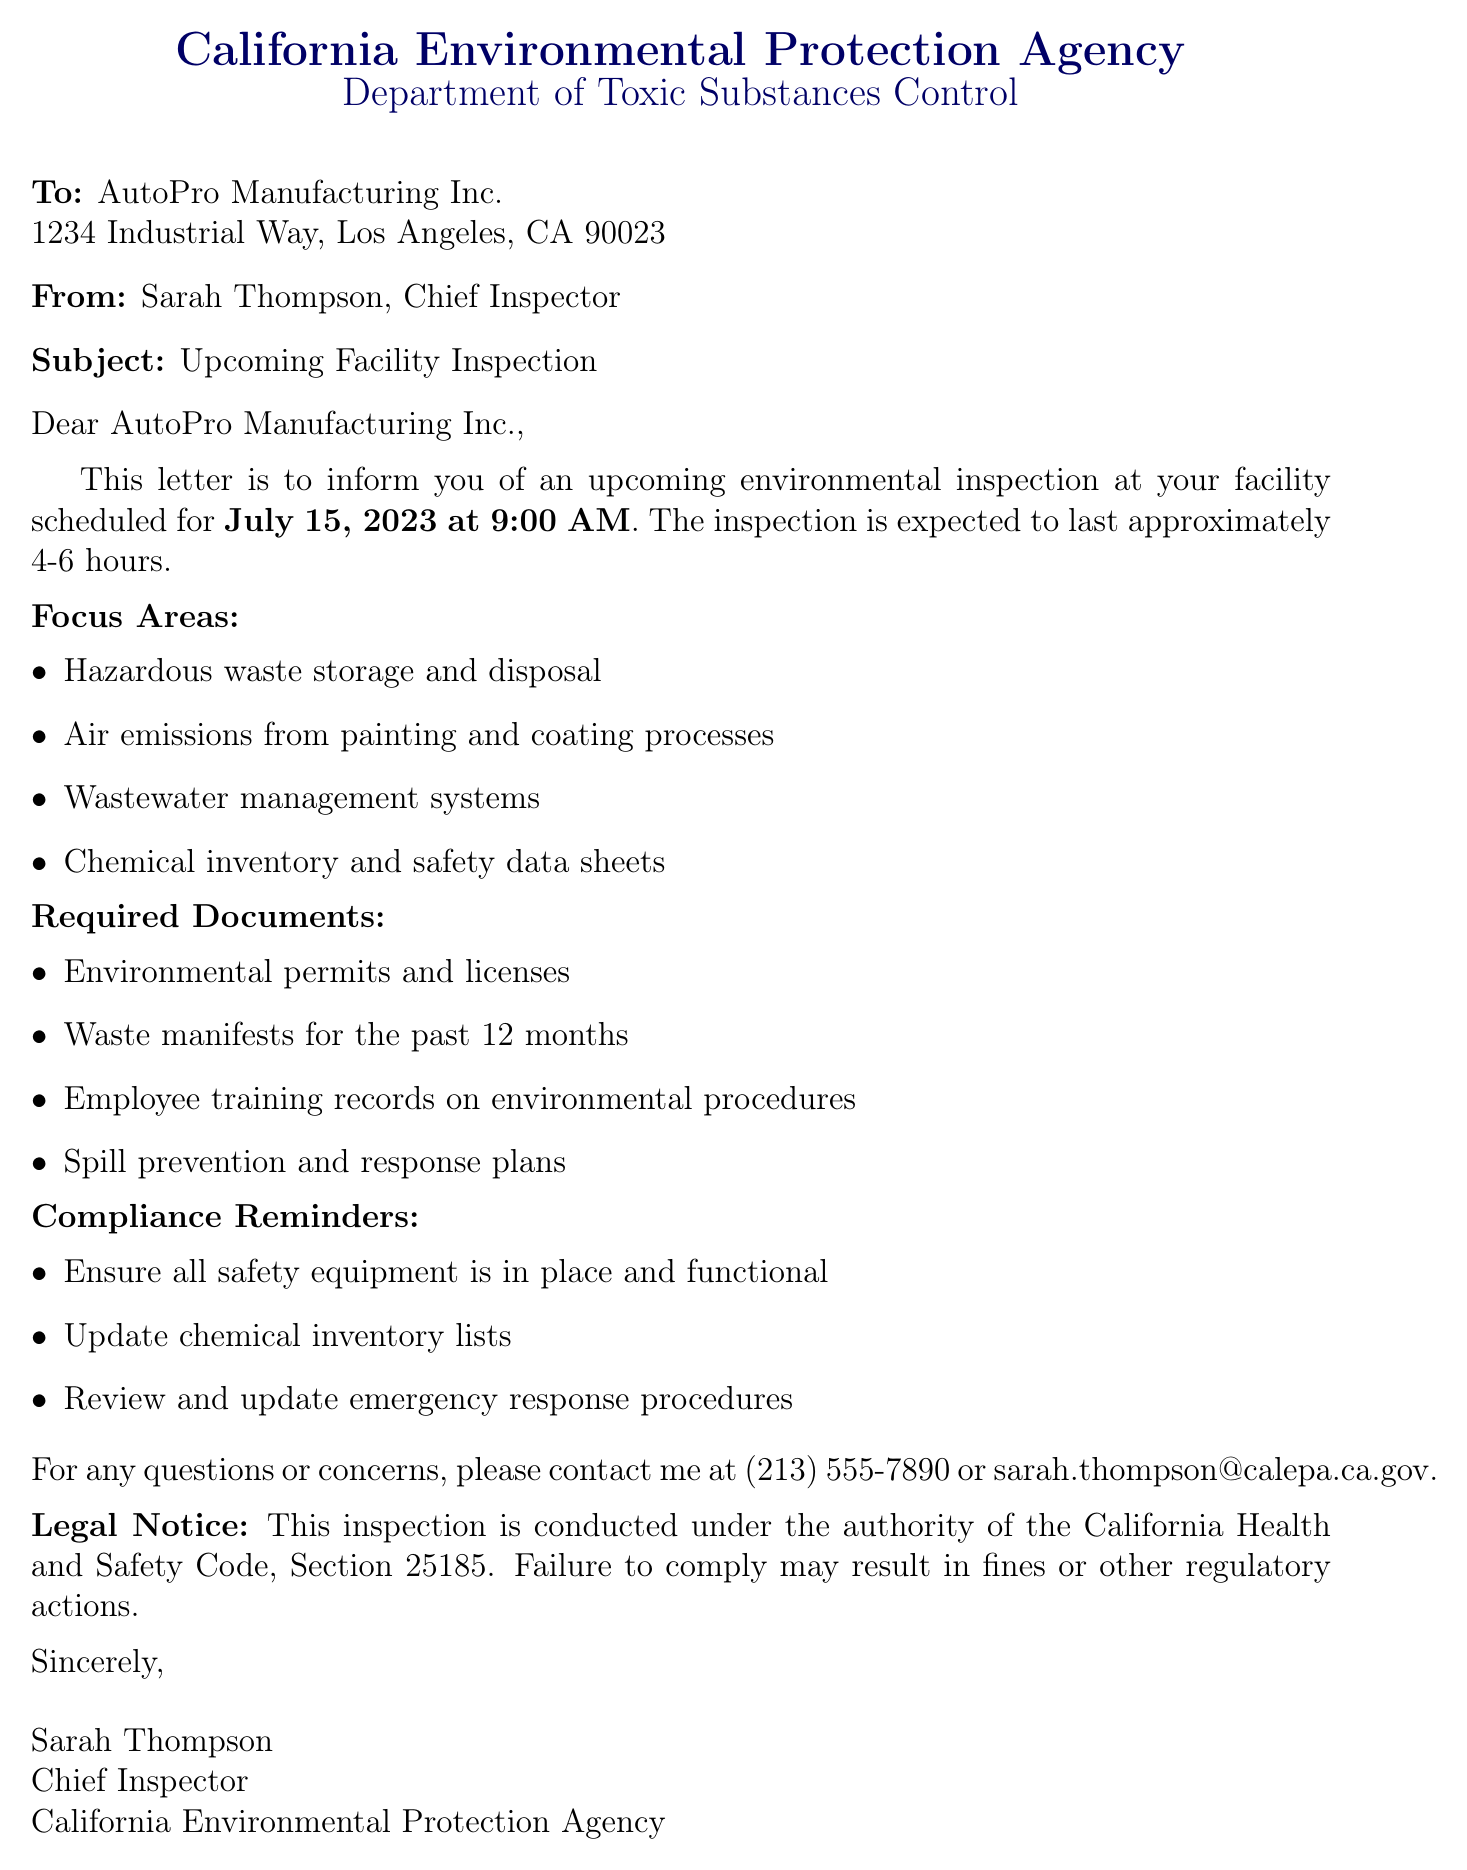What is the inspection date? The inspection date is specifically mentioned in the document as July 15, 2023.
Answer: July 15, 2023 Who is the Chief Inspector? The document states that Sarah Thompson holds the position of Chief Inspector.
Answer: Sarah Thompson How long is the inspection expected to last? The document indicates that the inspection will last approximately 4-6 hours.
Answer: Approximately 4-6 hours What are the focus areas of the inspection? The document lists several focus areas including hazardous waste storage and disposal, air emissions, and others.
Answer: Hazardous waste storage and disposal, air emissions from painting and coating processes, wastewater management systems, chemical inventory and safety data sheets What documents are required for the inspection? The document specifies that environmental permits, waste manifests, employee training records, and spill prevention plans are required.
Answer: Environmental permits and licenses, waste manifests for the past 12 months, employee training records on environmental procedures, spill prevention and response plans What is the contact phone number provided? The document includes a contact phone number for inquiries, which is (213) 555-7890.
Answer: (213) 555-7890 What should be ensured regarding safety equipment? The document reminds to ensure that all safety equipment is in place and functional.
Answer: Ensure all safety equipment is in place and functional Under what authority is the inspection conducted? The document mentions the inspection is conducted under the authority of the California Health and Safety Code, Section 25185.
Answer: California Health and Safety Code, Section 25185 